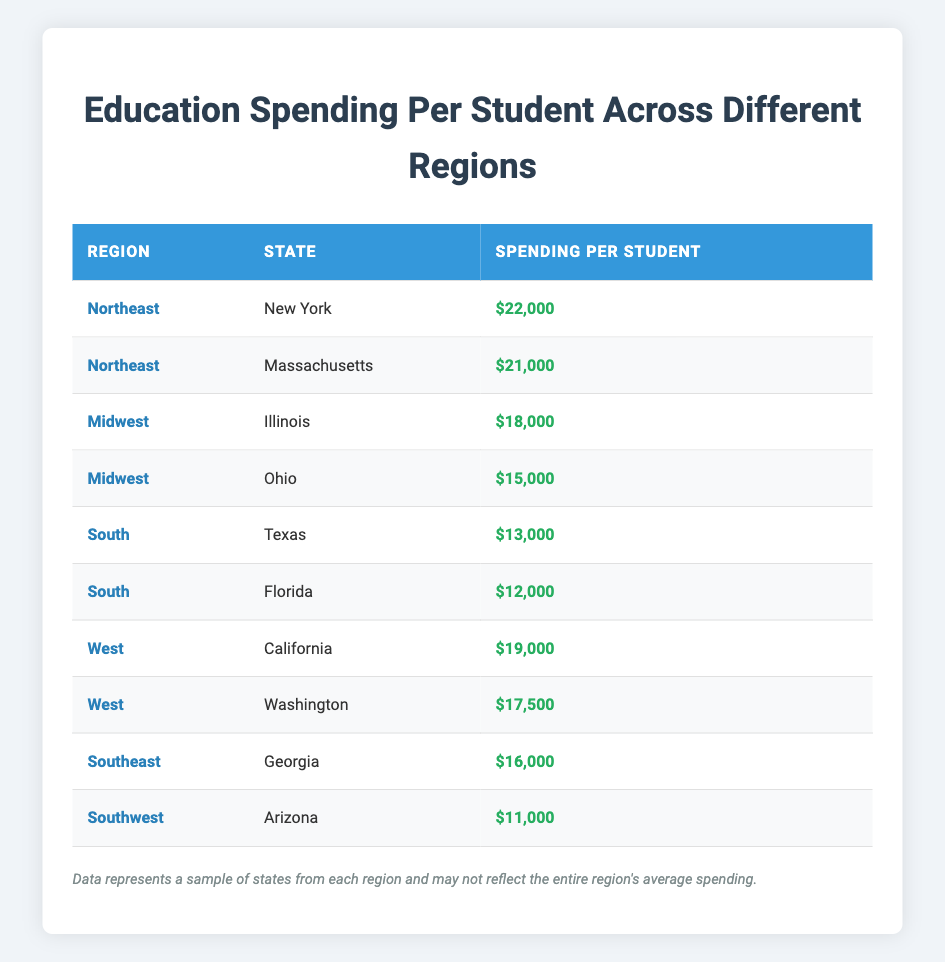What is the spending per student in New York? According to the table, New York is listed under the Northeast region with a spending per student figure of $22,000.
Answer: $22,000 Which state has the lowest spending per student, and what is that amount? The table indicates that Arizona, in the Southwest region, has the lowest spending per student at $11,000.
Answer: Arizona, $11,000 What is the average spending per student in the South region? To find the average, sum the spending per student for Texas ($13,000) and Florida ($12,000), which equals $25,000. Then, divide by 2, leading to an average of $25,000 / 2 = $12,500.
Answer: $12,500 Is spending per student in Georgia higher than in California? Georgia has a spending per student of $16,000, while California has a higher spending amount of $19,000. Thus, the fact is false.
Answer: No Which region has the highest single spending per student, and what is the amount? The Northeast region has New York spending $22,000 per student, the highest among all regions.
Answer: Northeast, $22,000 What is the difference in spending per student between the Midwest and the South? The Midwest average spending (Illinois at $18,000 and Ohio at $15,000) is calculated as ($18,000 + $15,000) / 2 = $16,500. The South average is calculated (Texas $13,000 and Florida $12,000) as ($13,000 + $12,000) / 2 = $12,500. The difference between $16,500 and $12,500 is $4,000.
Answer: $4,000 List all states with spending higher than $15,000. The states with spending over $15,000 from the table are New York ($22,000), Massachusetts ($21,000), Illinois ($18,000), California ($19,000), Washington ($17,500), and Georgia ($16,000).
Answer: New York, Massachusetts, Illinois, California, Washington, Georgia How many states have spending per student equal to or above $19,000? Only one state, New York, with spending of $22,000, meets the criterion of being $19,000 or more.
Answer: 1 